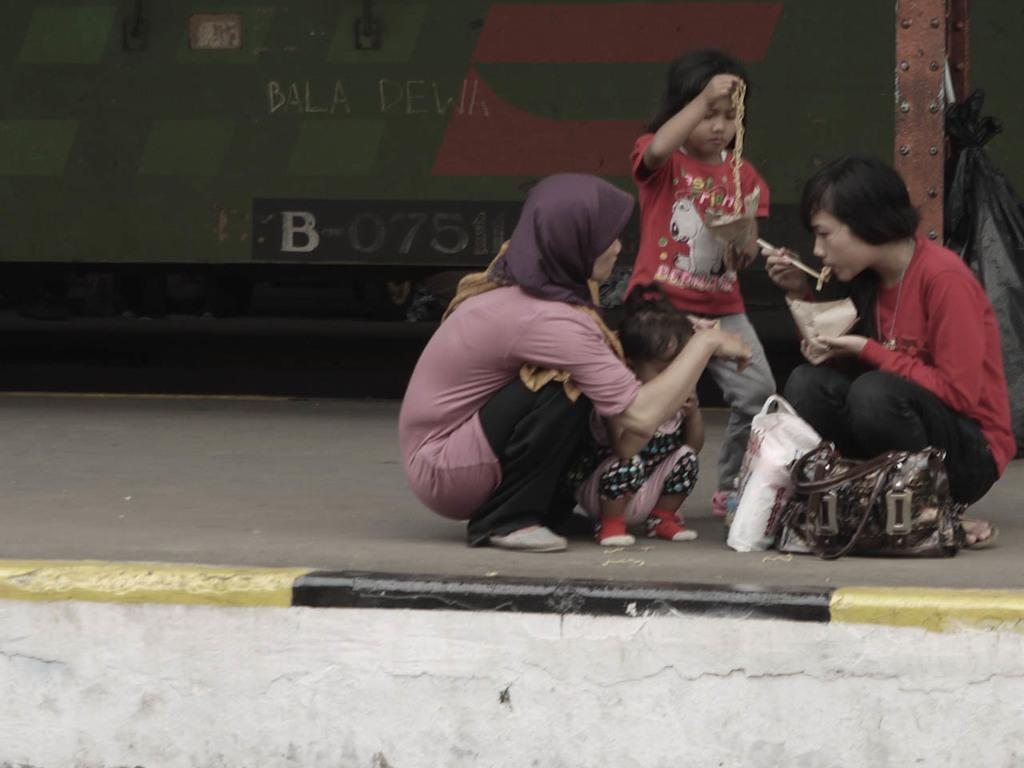How many people are in the image? There are four people in the image. What are two of the people holding in their hands? Two of the people are holding packets in their hands. Can you describe any other objects visible in the image? There is a plastic cover and a metal rod present in the image. What can be seen in the background of the image? There is a wall and a banner in the background of the image. What type of comb is being used by the people in the image? There is no comb visible in the image. What is the chance of winning a prize in the image? There is no indication of a prize or a game in the image, so it's not possible to determine the chance of winning a prize. 